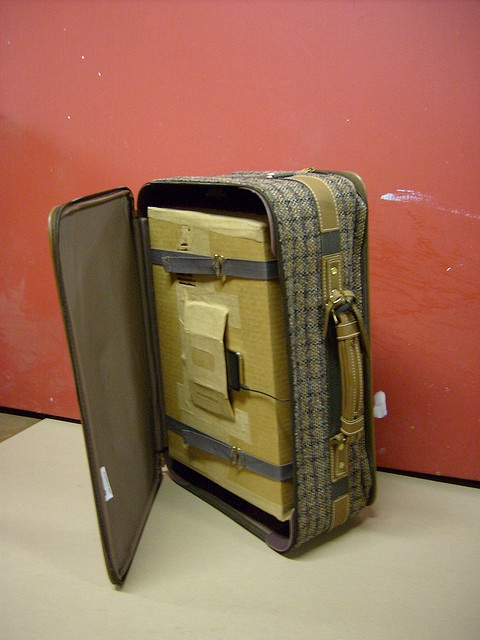Describe the objects in this image and their specific colors. I can see suitcase in brown, olive, black, and gray tones and cell phone in brown, black, and olive tones in this image. 